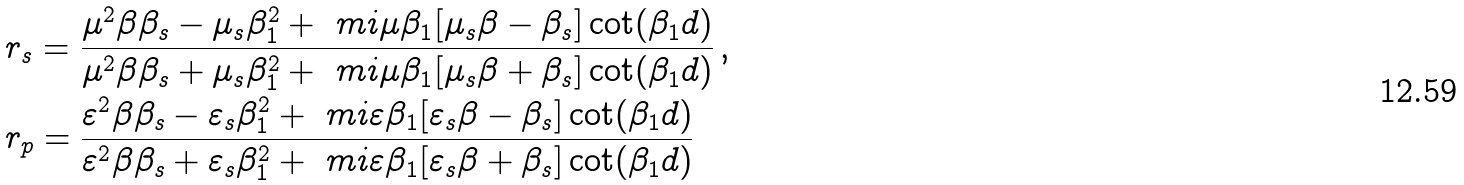<formula> <loc_0><loc_0><loc_500><loc_500>& r _ { s } = \frac { \mu ^ { 2 } \beta \beta _ { s } - \mu _ { s } \beta _ { 1 } ^ { 2 } + \ m i \mu \beta _ { 1 } [ \mu _ { s } \beta - \beta _ { s } ] \cot ( \beta _ { 1 } d ) } { \mu ^ { 2 } \beta \beta _ { s } + \mu _ { s } \beta _ { 1 } ^ { 2 } + \ m i \mu \beta _ { 1 } [ \mu _ { s } \beta + \beta _ { s } ] \cot ( \beta _ { 1 } d ) } \, , \\ & r _ { p } = \frac { \varepsilon ^ { 2 } \beta \beta _ { s } - \varepsilon _ { s } \beta _ { 1 } ^ { 2 } + \ m i \varepsilon \beta _ { 1 } [ \varepsilon _ { s } \beta - \beta _ { s } ] \cot ( \beta _ { 1 } d ) } { \varepsilon ^ { 2 } \beta \beta _ { s } + \varepsilon _ { s } \beta _ { 1 } ^ { 2 } + \ m i \varepsilon \beta _ { 1 } [ \varepsilon _ { s } \beta + \beta _ { s } ] \cot ( \beta _ { 1 } d ) }</formula> 